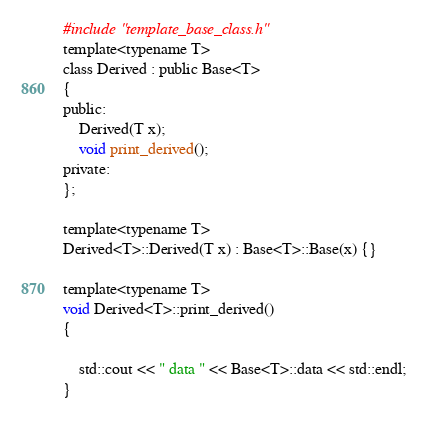Convert code to text. <code><loc_0><loc_0><loc_500><loc_500><_C_>#include "template_base_class.h"
template<typename T>
class Derived : public Base<T>
{
public:
    Derived(T x);
    void print_derived();
private:
};

template<typename T>
Derived<T>::Derived(T x) : Base<T>::Base(x) {}

template<typename T>
void Derived<T>::print_derived()
{

    std::cout << " data " << Base<T>::data << std::endl;
}
</code> 